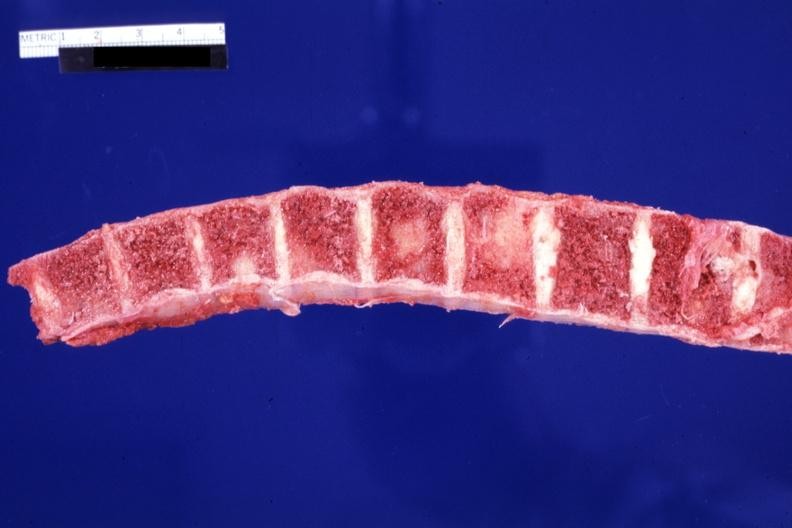does granulomata slide show several and large lesions?
Answer the question using a single word or phrase. No 